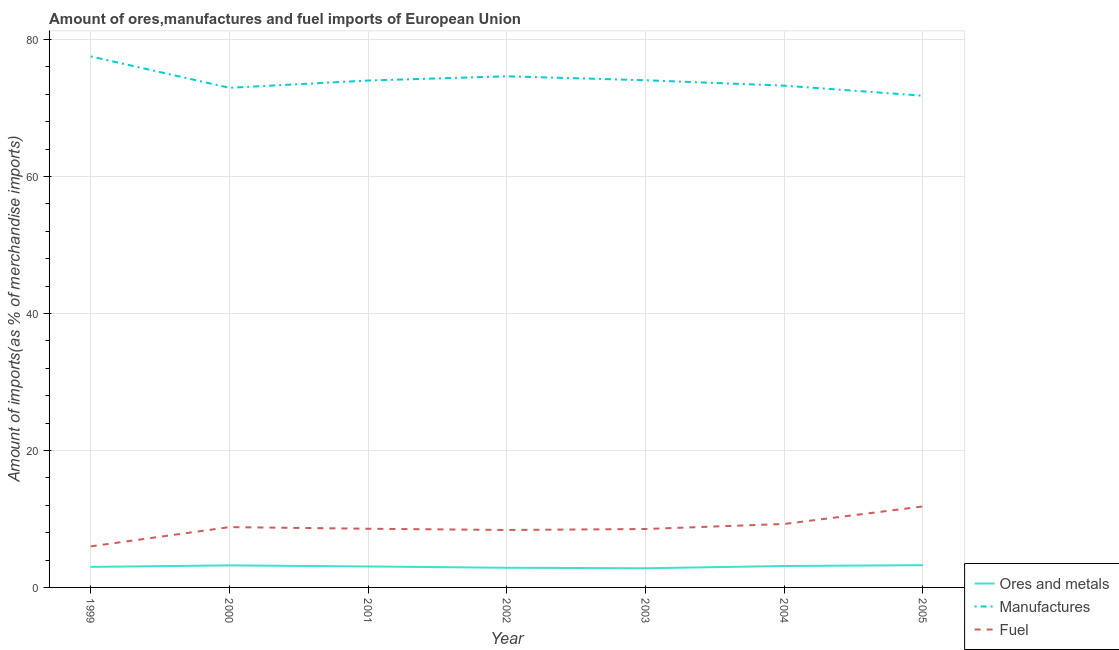What is the percentage of manufactures imports in 2002?
Make the answer very short. 74.62. Across all years, what is the maximum percentage of ores and metals imports?
Your answer should be very brief. 3.25. Across all years, what is the minimum percentage of ores and metals imports?
Offer a terse response. 2.8. In which year was the percentage of fuel imports minimum?
Give a very brief answer. 1999. What is the total percentage of ores and metals imports in the graph?
Offer a terse response. 21.32. What is the difference between the percentage of fuel imports in 2000 and that in 2002?
Your response must be concise. 0.42. What is the difference between the percentage of ores and metals imports in 1999 and the percentage of manufactures imports in 2005?
Your answer should be very brief. -68.78. What is the average percentage of manufactures imports per year?
Ensure brevity in your answer.  74.02. In the year 2001, what is the difference between the percentage of fuel imports and percentage of manufactures imports?
Keep it short and to the point. -65.43. What is the ratio of the percentage of manufactures imports in 2003 to that in 2004?
Ensure brevity in your answer.  1.01. What is the difference between the highest and the second highest percentage of manufactures imports?
Give a very brief answer. 2.9. What is the difference between the highest and the lowest percentage of fuel imports?
Your answer should be compact. 5.83. Is the sum of the percentage of fuel imports in 2000 and 2004 greater than the maximum percentage of manufactures imports across all years?
Provide a short and direct response. No. Is it the case that in every year, the sum of the percentage of ores and metals imports and percentage of manufactures imports is greater than the percentage of fuel imports?
Your answer should be very brief. Yes. Does the percentage of manufactures imports monotonically increase over the years?
Offer a terse response. No. Is the percentage of fuel imports strictly greater than the percentage of ores and metals imports over the years?
Your response must be concise. Yes. Is the percentage of fuel imports strictly less than the percentage of ores and metals imports over the years?
Offer a very short reply. No. What is the difference between two consecutive major ticks on the Y-axis?
Offer a very short reply. 20. Are the values on the major ticks of Y-axis written in scientific E-notation?
Your response must be concise. No. Does the graph contain grids?
Ensure brevity in your answer.  Yes. How are the legend labels stacked?
Your answer should be compact. Vertical. What is the title of the graph?
Keep it short and to the point. Amount of ores,manufactures and fuel imports of European Union. What is the label or title of the X-axis?
Your answer should be compact. Year. What is the label or title of the Y-axis?
Offer a terse response. Amount of imports(as % of merchandise imports). What is the Amount of imports(as % of merchandise imports) of Ores and metals in 1999?
Your answer should be compact. 3. What is the Amount of imports(as % of merchandise imports) in Manufactures in 1999?
Provide a short and direct response. 77.52. What is the Amount of imports(as % of merchandise imports) in Fuel in 1999?
Give a very brief answer. 5.99. What is the Amount of imports(as % of merchandise imports) of Ores and metals in 2000?
Your response must be concise. 3.22. What is the Amount of imports(as % of merchandise imports) of Manufactures in 2000?
Ensure brevity in your answer.  72.94. What is the Amount of imports(as % of merchandise imports) of Fuel in 2000?
Provide a short and direct response. 8.81. What is the Amount of imports(as % of merchandise imports) of Ores and metals in 2001?
Provide a succinct answer. 3.06. What is the Amount of imports(as % of merchandise imports) of Manufactures in 2001?
Your response must be concise. 74. What is the Amount of imports(as % of merchandise imports) of Fuel in 2001?
Offer a very short reply. 8.57. What is the Amount of imports(as % of merchandise imports) of Ores and metals in 2002?
Keep it short and to the point. 2.87. What is the Amount of imports(as % of merchandise imports) in Manufactures in 2002?
Offer a terse response. 74.62. What is the Amount of imports(as % of merchandise imports) of Fuel in 2002?
Ensure brevity in your answer.  8.39. What is the Amount of imports(as % of merchandise imports) in Ores and metals in 2003?
Make the answer very short. 2.8. What is the Amount of imports(as % of merchandise imports) in Manufactures in 2003?
Give a very brief answer. 74.04. What is the Amount of imports(as % of merchandise imports) in Fuel in 2003?
Provide a succinct answer. 8.53. What is the Amount of imports(as % of merchandise imports) of Ores and metals in 2004?
Offer a very short reply. 3.13. What is the Amount of imports(as % of merchandise imports) of Manufactures in 2004?
Provide a short and direct response. 73.25. What is the Amount of imports(as % of merchandise imports) in Fuel in 2004?
Keep it short and to the point. 9.26. What is the Amount of imports(as % of merchandise imports) of Ores and metals in 2005?
Keep it short and to the point. 3.25. What is the Amount of imports(as % of merchandise imports) of Manufactures in 2005?
Provide a short and direct response. 71.78. What is the Amount of imports(as % of merchandise imports) of Fuel in 2005?
Your response must be concise. 11.82. Across all years, what is the maximum Amount of imports(as % of merchandise imports) of Ores and metals?
Provide a short and direct response. 3.25. Across all years, what is the maximum Amount of imports(as % of merchandise imports) of Manufactures?
Offer a terse response. 77.52. Across all years, what is the maximum Amount of imports(as % of merchandise imports) in Fuel?
Provide a short and direct response. 11.82. Across all years, what is the minimum Amount of imports(as % of merchandise imports) in Ores and metals?
Your answer should be very brief. 2.8. Across all years, what is the minimum Amount of imports(as % of merchandise imports) in Manufactures?
Give a very brief answer. 71.78. Across all years, what is the minimum Amount of imports(as % of merchandise imports) of Fuel?
Your response must be concise. 5.99. What is the total Amount of imports(as % of merchandise imports) in Ores and metals in the graph?
Make the answer very short. 21.32. What is the total Amount of imports(as % of merchandise imports) in Manufactures in the graph?
Offer a terse response. 518.14. What is the total Amount of imports(as % of merchandise imports) in Fuel in the graph?
Provide a short and direct response. 61.37. What is the difference between the Amount of imports(as % of merchandise imports) in Ores and metals in 1999 and that in 2000?
Your answer should be compact. -0.22. What is the difference between the Amount of imports(as % of merchandise imports) in Manufactures in 1999 and that in 2000?
Offer a very short reply. 4.58. What is the difference between the Amount of imports(as % of merchandise imports) in Fuel in 1999 and that in 2000?
Your answer should be compact. -2.81. What is the difference between the Amount of imports(as % of merchandise imports) in Ores and metals in 1999 and that in 2001?
Make the answer very short. -0.06. What is the difference between the Amount of imports(as % of merchandise imports) of Manufactures in 1999 and that in 2001?
Offer a terse response. 3.52. What is the difference between the Amount of imports(as % of merchandise imports) of Fuel in 1999 and that in 2001?
Make the answer very short. -2.57. What is the difference between the Amount of imports(as % of merchandise imports) of Ores and metals in 1999 and that in 2002?
Offer a very short reply. 0.13. What is the difference between the Amount of imports(as % of merchandise imports) in Manufactures in 1999 and that in 2002?
Provide a succinct answer. 2.9. What is the difference between the Amount of imports(as % of merchandise imports) of Fuel in 1999 and that in 2002?
Your answer should be compact. -2.39. What is the difference between the Amount of imports(as % of merchandise imports) of Ores and metals in 1999 and that in 2003?
Provide a short and direct response. 0.2. What is the difference between the Amount of imports(as % of merchandise imports) in Manufactures in 1999 and that in 2003?
Ensure brevity in your answer.  3.48. What is the difference between the Amount of imports(as % of merchandise imports) of Fuel in 1999 and that in 2003?
Provide a short and direct response. -2.53. What is the difference between the Amount of imports(as % of merchandise imports) of Ores and metals in 1999 and that in 2004?
Give a very brief answer. -0.13. What is the difference between the Amount of imports(as % of merchandise imports) in Manufactures in 1999 and that in 2004?
Provide a succinct answer. 4.27. What is the difference between the Amount of imports(as % of merchandise imports) of Fuel in 1999 and that in 2004?
Provide a succinct answer. -3.27. What is the difference between the Amount of imports(as % of merchandise imports) in Ores and metals in 1999 and that in 2005?
Ensure brevity in your answer.  -0.25. What is the difference between the Amount of imports(as % of merchandise imports) in Manufactures in 1999 and that in 2005?
Provide a succinct answer. 5.74. What is the difference between the Amount of imports(as % of merchandise imports) in Fuel in 1999 and that in 2005?
Your answer should be very brief. -5.83. What is the difference between the Amount of imports(as % of merchandise imports) of Ores and metals in 2000 and that in 2001?
Your response must be concise. 0.16. What is the difference between the Amount of imports(as % of merchandise imports) of Manufactures in 2000 and that in 2001?
Ensure brevity in your answer.  -1.06. What is the difference between the Amount of imports(as % of merchandise imports) of Fuel in 2000 and that in 2001?
Keep it short and to the point. 0.24. What is the difference between the Amount of imports(as % of merchandise imports) of Ores and metals in 2000 and that in 2002?
Offer a terse response. 0.35. What is the difference between the Amount of imports(as % of merchandise imports) in Manufactures in 2000 and that in 2002?
Your response must be concise. -1.68. What is the difference between the Amount of imports(as % of merchandise imports) of Fuel in 2000 and that in 2002?
Provide a short and direct response. 0.42. What is the difference between the Amount of imports(as % of merchandise imports) of Ores and metals in 2000 and that in 2003?
Keep it short and to the point. 0.42. What is the difference between the Amount of imports(as % of merchandise imports) of Manufactures in 2000 and that in 2003?
Give a very brief answer. -1.1. What is the difference between the Amount of imports(as % of merchandise imports) in Fuel in 2000 and that in 2003?
Provide a short and direct response. 0.28. What is the difference between the Amount of imports(as % of merchandise imports) in Ores and metals in 2000 and that in 2004?
Your answer should be very brief. 0.09. What is the difference between the Amount of imports(as % of merchandise imports) of Manufactures in 2000 and that in 2004?
Make the answer very short. -0.32. What is the difference between the Amount of imports(as % of merchandise imports) in Fuel in 2000 and that in 2004?
Give a very brief answer. -0.46. What is the difference between the Amount of imports(as % of merchandise imports) of Ores and metals in 2000 and that in 2005?
Your response must be concise. -0.03. What is the difference between the Amount of imports(as % of merchandise imports) in Manufactures in 2000 and that in 2005?
Your answer should be compact. 1.16. What is the difference between the Amount of imports(as % of merchandise imports) in Fuel in 2000 and that in 2005?
Your response must be concise. -3.02. What is the difference between the Amount of imports(as % of merchandise imports) of Ores and metals in 2001 and that in 2002?
Offer a terse response. 0.19. What is the difference between the Amount of imports(as % of merchandise imports) in Manufactures in 2001 and that in 2002?
Provide a short and direct response. -0.62. What is the difference between the Amount of imports(as % of merchandise imports) of Fuel in 2001 and that in 2002?
Offer a very short reply. 0.18. What is the difference between the Amount of imports(as % of merchandise imports) of Ores and metals in 2001 and that in 2003?
Ensure brevity in your answer.  0.26. What is the difference between the Amount of imports(as % of merchandise imports) in Manufactures in 2001 and that in 2003?
Provide a short and direct response. -0.04. What is the difference between the Amount of imports(as % of merchandise imports) of Fuel in 2001 and that in 2003?
Provide a succinct answer. 0.04. What is the difference between the Amount of imports(as % of merchandise imports) of Ores and metals in 2001 and that in 2004?
Offer a very short reply. -0.07. What is the difference between the Amount of imports(as % of merchandise imports) of Manufactures in 2001 and that in 2004?
Your answer should be compact. 0.75. What is the difference between the Amount of imports(as % of merchandise imports) in Fuel in 2001 and that in 2004?
Ensure brevity in your answer.  -0.7. What is the difference between the Amount of imports(as % of merchandise imports) of Ores and metals in 2001 and that in 2005?
Make the answer very short. -0.19. What is the difference between the Amount of imports(as % of merchandise imports) of Manufactures in 2001 and that in 2005?
Your response must be concise. 2.22. What is the difference between the Amount of imports(as % of merchandise imports) in Fuel in 2001 and that in 2005?
Offer a terse response. -3.26. What is the difference between the Amount of imports(as % of merchandise imports) in Ores and metals in 2002 and that in 2003?
Provide a succinct answer. 0.07. What is the difference between the Amount of imports(as % of merchandise imports) of Manufactures in 2002 and that in 2003?
Your answer should be compact. 0.58. What is the difference between the Amount of imports(as % of merchandise imports) in Fuel in 2002 and that in 2003?
Your answer should be compact. -0.14. What is the difference between the Amount of imports(as % of merchandise imports) of Ores and metals in 2002 and that in 2004?
Give a very brief answer. -0.26. What is the difference between the Amount of imports(as % of merchandise imports) in Manufactures in 2002 and that in 2004?
Keep it short and to the point. 1.36. What is the difference between the Amount of imports(as % of merchandise imports) of Fuel in 2002 and that in 2004?
Provide a succinct answer. -0.88. What is the difference between the Amount of imports(as % of merchandise imports) of Ores and metals in 2002 and that in 2005?
Ensure brevity in your answer.  -0.38. What is the difference between the Amount of imports(as % of merchandise imports) of Manufactures in 2002 and that in 2005?
Offer a very short reply. 2.84. What is the difference between the Amount of imports(as % of merchandise imports) of Fuel in 2002 and that in 2005?
Offer a very short reply. -3.44. What is the difference between the Amount of imports(as % of merchandise imports) in Ores and metals in 2003 and that in 2004?
Your answer should be very brief. -0.33. What is the difference between the Amount of imports(as % of merchandise imports) of Manufactures in 2003 and that in 2004?
Give a very brief answer. 0.79. What is the difference between the Amount of imports(as % of merchandise imports) in Fuel in 2003 and that in 2004?
Make the answer very short. -0.74. What is the difference between the Amount of imports(as % of merchandise imports) in Ores and metals in 2003 and that in 2005?
Make the answer very short. -0.45. What is the difference between the Amount of imports(as % of merchandise imports) in Manufactures in 2003 and that in 2005?
Provide a short and direct response. 2.26. What is the difference between the Amount of imports(as % of merchandise imports) of Fuel in 2003 and that in 2005?
Ensure brevity in your answer.  -3.3. What is the difference between the Amount of imports(as % of merchandise imports) in Ores and metals in 2004 and that in 2005?
Your answer should be compact. -0.12. What is the difference between the Amount of imports(as % of merchandise imports) in Manufactures in 2004 and that in 2005?
Keep it short and to the point. 1.47. What is the difference between the Amount of imports(as % of merchandise imports) of Fuel in 2004 and that in 2005?
Offer a terse response. -2.56. What is the difference between the Amount of imports(as % of merchandise imports) of Ores and metals in 1999 and the Amount of imports(as % of merchandise imports) of Manufactures in 2000?
Make the answer very short. -69.94. What is the difference between the Amount of imports(as % of merchandise imports) in Ores and metals in 1999 and the Amount of imports(as % of merchandise imports) in Fuel in 2000?
Provide a succinct answer. -5.81. What is the difference between the Amount of imports(as % of merchandise imports) of Manufactures in 1999 and the Amount of imports(as % of merchandise imports) of Fuel in 2000?
Ensure brevity in your answer.  68.71. What is the difference between the Amount of imports(as % of merchandise imports) in Ores and metals in 1999 and the Amount of imports(as % of merchandise imports) in Manufactures in 2001?
Provide a succinct answer. -71. What is the difference between the Amount of imports(as % of merchandise imports) in Ores and metals in 1999 and the Amount of imports(as % of merchandise imports) in Fuel in 2001?
Your answer should be compact. -5.57. What is the difference between the Amount of imports(as % of merchandise imports) in Manufactures in 1999 and the Amount of imports(as % of merchandise imports) in Fuel in 2001?
Your response must be concise. 68.95. What is the difference between the Amount of imports(as % of merchandise imports) of Ores and metals in 1999 and the Amount of imports(as % of merchandise imports) of Manufactures in 2002?
Offer a terse response. -71.62. What is the difference between the Amount of imports(as % of merchandise imports) in Ores and metals in 1999 and the Amount of imports(as % of merchandise imports) in Fuel in 2002?
Give a very brief answer. -5.39. What is the difference between the Amount of imports(as % of merchandise imports) in Manufactures in 1999 and the Amount of imports(as % of merchandise imports) in Fuel in 2002?
Your response must be concise. 69.13. What is the difference between the Amount of imports(as % of merchandise imports) of Ores and metals in 1999 and the Amount of imports(as % of merchandise imports) of Manufactures in 2003?
Your response must be concise. -71.04. What is the difference between the Amount of imports(as % of merchandise imports) in Ores and metals in 1999 and the Amount of imports(as % of merchandise imports) in Fuel in 2003?
Give a very brief answer. -5.53. What is the difference between the Amount of imports(as % of merchandise imports) in Manufactures in 1999 and the Amount of imports(as % of merchandise imports) in Fuel in 2003?
Ensure brevity in your answer.  68.99. What is the difference between the Amount of imports(as % of merchandise imports) of Ores and metals in 1999 and the Amount of imports(as % of merchandise imports) of Manufactures in 2004?
Your answer should be compact. -70.25. What is the difference between the Amount of imports(as % of merchandise imports) in Ores and metals in 1999 and the Amount of imports(as % of merchandise imports) in Fuel in 2004?
Your response must be concise. -6.27. What is the difference between the Amount of imports(as % of merchandise imports) in Manufactures in 1999 and the Amount of imports(as % of merchandise imports) in Fuel in 2004?
Your answer should be compact. 68.25. What is the difference between the Amount of imports(as % of merchandise imports) of Ores and metals in 1999 and the Amount of imports(as % of merchandise imports) of Manufactures in 2005?
Offer a very short reply. -68.78. What is the difference between the Amount of imports(as % of merchandise imports) in Ores and metals in 1999 and the Amount of imports(as % of merchandise imports) in Fuel in 2005?
Provide a succinct answer. -8.83. What is the difference between the Amount of imports(as % of merchandise imports) of Manufactures in 1999 and the Amount of imports(as % of merchandise imports) of Fuel in 2005?
Offer a terse response. 65.69. What is the difference between the Amount of imports(as % of merchandise imports) in Ores and metals in 2000 and the Amount of imports(as % of merchandise imports) in Manufactures in 2001?
Ensure brevity in your answer.  -70.78. What is the difference between the Amount of imports(as % of merchandise imports) of Ores and metals in 2000 and the Amount of imports(as % of merchandise imports) of Fuel in 2001?
Provide a short and direct response. -5.35. What is the difference between the Amount of imports(as % of merchandise imports) of Manufactures in 2000 and the Amount of imports(as % of merchandise imports) of Fuel in 2001?
Make the answer very short. 64.37. What is the difference between the Amount of imports(as % of merchandise imports) in Ores and metals in 2000 and the Amount of imports(as % of merchandise imports) in Manufactures in 2002?
Provide a short and direct response. -71.4. What is the difference between the Amount of imports(as % of merchandise imports) in Ores and metals in 2000 and the Amount of imports(as % of merchandise imports) in Fuel in 2002?
Provide a succinct answer. -5.17. What is the difference between the Amount of imports(as % of merchandise imports) of Manufactures in 2000 and the Amount of imports(as % of merchandise imports) of Fuel in 2002?
Make the answer very short. 64.55. What is the difference between the Amount of imports(as % of merchandise imports) of Ores and metals in 2000 and the Amount of imports(as % of merchandise imports) of Manufactures in 2003?
Keep it short and to the point. -70.82. What is the difference between the Amount of imports(as % of merchandise imports) of Ores and metals in 2000 and the Amount of imports(as % of merchandise imports) of Fuel in 2003?
Your response must be concise. -5.31. What is the difference between the Amount of imports(as % of merchandise imports) in Manufactures in 2000 and the Amount of imports(as % of merchandise imports) in Fuel in 2003?
Offer a terse response. 64.41. What is the difference between the Amount of imports(as % of merchandise imports) of Ores and metals in 2000 and the Amount of imports(as % of merchandise imports) of Manufactures in 2004?
Keep it short and to the point. -70.04. What is the difference between the Amount of imports(as % of merchandise imports) of Ores and metals in 2000 and the Amount of imports(as % of merchandise imports) of Fuel in 2004?
Provide a succinct answer. -6.05. What is the difference between the Amount of imports(as % of merchandise imports) in Manufactures in 2000 and the Amount of imports(as % of merchandise imports) in Fuel in 2004?
Provide a short and direct response. 63.67. What is the difference between the Amount of imports(as % of merchandise imports) of Ores and metals in 2000 and the Amount of imports(as % of merchandise imports) of Manufactures in 2005?
Give a very brief answer. -68.56. What is the difference between the Amount of imports(as % of merchandise imports) in Ores and metals in 2000 and the Amount of imports(as % of merchandise imports) in Fuel in 2005?
Give a very brief answer. -8.61. What is the difference between the Amount of imports(as % of merchandise imports) of Manufactures in 2000 and the Amount of imports(as % of merchandise imports) of Fuel in 2005?
Make the answer very short. 61.11. What is the difference between the Amount of imports(as % of merchandise imports) of Ores and metals in 2001 and the Amount of imports(as % of merchandise imports) of Manufactures in 2002?
Make the answer very short. -71.56. What is the difference between the Amount of imports(as % of merchandise imports) of Ores and metals in 2001 and the Amount of imports(as % of merchandise imports) of Fuel in 2002?
Ensure brevity in your answer.  -5.33. What is the difference between the Amount of imports(as % of merchandise imports) in Manufactures in 2001 and the Amount of imports(as % of merchandise imports) in Fuel in 2002?
Offer a terse response. 65.61. What is the difference between the Amount of imports(as % of merchandise imports) of Ores and metals in 2001 and the Amount of imports(as % of merchandise imports) of Manufactures in 2003?
Provide a short and direct response. -70.98. What is the difference between the Amount of imports(as % of merchandise imports) in Ores and metals in 2001 and the Amount of imports(as % of merchandise imports) in Fuel in 2003?
Provide a succinct answer. -5.47. What is the difference between the Amount of imports(as % of merchandise imports) of Manufactures in 2001 and the Amount of imports(as % of merchandise imports) of Fuel in 2003?
Your answer should be compact. 65.47. What is the difference between the Amount of imports(as % of merchandise imports) of Ores and metals in 2001 and the Amount of imports(as % of merchandise imports) of Manufactures in 2004?
Your answer should be compact. -70.19. What is the difference between the Amount of imports(as % of merchandise imports) in Ores and metals in 2001 and the Amount of imports(as % of merchandise imports) in Fuel in 2004?
Make the answer very short. -6.2. What is the difference between the Amount of imports(as % of merchandise imports) in Manufactures in 2001 and the Amount of imports(as % of merchandise imports) in Fuel in 2004?
Keep it short and to the point. 64.73. What is the difference between the Amount of imports(as % of merchandise imports) of Ores and metals in 2001 and the Amount of imports(as % of merchandise imports) of Manufactures in 2005?
Provide a succinct answer. -68.72. What is the difference between the Amount of imports(as % of merchandise imports) of Ores and metals in 2001 and the Amount of imports(as % of merchandise imports) of Fuel in 2005?
Ensure brevity in your answer.  -8.76. What is the difference between the Amount of imports(as % of merchandise imports) of Manufactures in 2001 and the Amount of imports(as % of merchandise imports) of Fuel in 2005?
Keep it short and to the point. 62.17. What is the difference between the Amount of imports(as % of merchandise imports) in Ores and metals in 2002 and the Amount of imports(as % of merchandise imports) in Manufactures in 2003?
Your answer should be very brief. -71.17. What is the difference between the Amount of imports(as % of merchandise imports) in Ores and metals in 2002 and the Amount of imports(as % of merchandise imports) in Fuel in 2003?
Your answer should be very brief. -5.66. What is the difference between the Amount of imports(as % of merchandise imports) of Manufactures in 2002 and the Amount of imports(as % of merchandise imports) of Fuel in 2003?
Offer a very short reply. 66.09. What is the difference between the Amount of imports(as % of merchandise imports) in Ores and metals in 2002 and the Amount of imports(as % of merchandise imports) in Manufactures in 2004?
Ensure brevity in your answer.  -70.38. What is the difference between the Amount of imports(as % of merchandise imports) in Ores and metals in 2002 and the Amount of imports(as % of merchandise imports) in Fuel in 2004?
Provide a short and direct response. -6.39. What is the difference between the Amount of imports(as % of merchandise imports) in Manufactures in 2002 and the Amount of imports(as % of merchandise imports) in Fuel in 2004?
Provide a short and direct response. 65.35. What is the difference between the Amount of imports(as % of merchandise imports) of Ores and metals in 2002 and the Amount of imports(as % of merchandise imports) of Manufactures in 2005?
Provide a short and direct response. -68.91. What is the difference between the Amount of imports(as % of merchandise imports) of Ores and metals in 2002 and the Amount of imports(as % of merchandise imports) of Fuel in 2005?
Give a very brief answer. -8.95. What is the difference between the Amount of imports(as % of merchandise imports) of Manufactures in 2002 and the Amount of imports(as % of merchandise imports) of Fuel in 2005?
Your response must be concise. 62.79. What is the difference between the Amount of imports(as % of merchandise imports) in Ores and metals in 2003 and the Amount of imports(as % of merchandise imports) in Manufactures in 2004?
Offer a terse response. -70.46. What is the difference between the Amount of imports(as % of merchandise imports) of Ores and metals in 2003 and the Amount of imports(as % of merchandise imports) of Fuel in 2004?
Give a very brief answer. -6.47. What is the difference between the Amount of imports(as % of merchandise imports) of Manufactures in 2003 and the Amount of imports(as % of merchandise imports) of Fuel in 2004?
Give a very brief answer. 64.78. What is the difference between the Amount of imports(as % of merchandise imports) in Ores and metals in 2003 and the Amount of imports(as % of merchandise imports) in Manufactures in 2005?
Provide a succinct answer. -68.98. What is the difference between the Amount of imports(as % of merchandise imports) of Ores and metals in 2003 and the Amount of imports(as % of merchandise imports) of Fuel in 2005?
Offer a terse response. -9.03. What is the difference between the Amount of imports(as % of merchandise imports) of Manufactures in 2003 and the Amount of imports(as % of merchandise imports) of Fuel in 2005?
Your answer should be very brief. 62.22. What is the difference between the Amount of imports(as % of merchandise imports) of Ores and metals in 2004 and the Amount of imports(as % of merchandise imports) of Manufactures in 2005?
Your response must be concise. -68.65. What is the difference between the Amount of imports(as % of merchandise imports) in Ores and metals in 2004 and the Amount of imports(as % of merchandise imports) in Fuel in 2005?
Keep it short and to the point. -8.7. What is the difference between the Amount of imports(as % of merchandise imports) in Manufactures in 2004 and the Amount of imports(as % of merchandise imports) in Fuel in 2005?
Offer a terse response. 61.43. What is the average Amount of imports(as % of merchandise imports) of Ores and metals per year?
Ensure brevity in your answer.  3.05. What is the average Amount of imports(as % of merchandise imports) in Manufactures per year?
Give a very brief answer. 74.02. What is the average Amount of imports(as % of merchandise imports) of Fuel per year?
Give a very brief answer. 8.77. In the year 1999, what is the difference between the Amount of imports(as % of merchandise imports) of Ores and metals and Amount of imports(as % of merchandise imports) of Manufactures?
Offer a terse response. -74.52. In the year 1999, what is the difference between the Amount of imports(as % of merchandise imports) in Ores and metals and Amount of imports(as % of merchandise imports) in Fuel?
Ensure brevity in your answer.  -3. In the year 1999, what is the difference between the Amount of imports(as % of merchandise imports) of Manufactures and Amount of imports(as % of merchandise imports) of Fuel?
Your answer should be compact. 71.52. In the year 2000, what is the difference between the Amount of imports(as % of merchandise imports) of Ores and metals and Amount of imports(as % of merchandise imports) of Manufactures?
Keep it short and to the point. -69.72. In the year 2000, what is the difference between the Amount of imports(as % of merchandise imports) in Ores and metals and Amount of imports(as % of merchandise imports) in Fuel?
Give a very brief answer. -5.59. In the year 2000, what is the difference between the Amount of imports(as % of merchandise imports) of Manufactures and Amount of imports(as % of merchandise imports) of Fuel?
Ensure brevity in your answer.  64.13. In the year 2001, what is the difference between the Amount of imports(as % of merchandise imports) in Ores and metals and Amount of imports(as % of merchandise imports) in Manufactures?
Your answer should be very brief. -70.94. In the year 2001, what is the difference between the Amount of imports(as % of merchandise imports) in Ores and metals and Amount of imports(as % of merchandise imports) in Fuel?
Provide a short and direct response. -5.51. In the year 2001, what is the difference between the Amount of imports(as % of merchandise imports) in Manufactures and Amount of imports(as % of merchandise imports) in Fuel?
Provide a short and direct response. 65.43. In the year 2002, what is the difference between the Amount of imports(as % of merchandise imports) in Ores and metals and Amount of imports(as % of merchandise imports) in Manufactures?
Your response must be concise. -71.75. In the year 2002, what is the difference between the Amount of imports(as % of merchandise imports) in Ores and metals and Amount of imports(as % of merchandise imports) in Fuel?
Keep it short and to the point. -5.52. In the year 2002, what is the difference between the Amount of imports(as % of merchandise imports) of Manufactures and Amount of imports(as % of merchandise imports) of Fuel?
Make the answer very short. 66.23. In the year 2003, what is the difference between the Amount of imports(as % of merchandise imports) of Ores and metals and Amount of imports(as % of merchandise imports) of Manufactures?
Your response must be concise. -71.24. In the year 2003, what is the difference between the Amount of imports(as % of merchandise imports) in Ores and metals and Amount of imports(as % of merchandise imports) in Fuel?
Ensure brevity in your answer.  -5.73. In the year 2003, what is the difference between the Amount of imports(as % of merchandise imports) in Manufactures and Amount of imports(as % of merchandise imports) in Fuel?
Your answer should be compact. 65.51. In the year 2004, what is the difference between the Amount of imports(as % of merchandise imports) in Ores and metals and Amount of imports(as % of merchandise imports) in Manufactures?
Offer a terse response. -70.12. In the year 2004, what is the difference between the Amount of imports(as % of merchandise imports) in Ores and metals and Amount of imports(as % of merchandise imports) in Fuel?
Provide a succinct answer. -6.14. In the year 2004, what is the difference between the Amount of imports(as % of merchandise imports) in Manufactures and Amount of imports(as % of merchandise imports) in Fuel?
Give a very brief answer. 63.99. In the year 2005, what is the difference between the Amount of imports(as % of merchandise imports) of Ores and metals and Amount of imports(as % of merchandise imports) of Manufactures?
Ensure brevity in your answer.  -68.53. In the year 2005, what is the difference between the Amount of imports(as % of merchandise imports) in Ores and metals and Amount of imports(as % of merchandise imports) in Fuel?
Provide a succinct answer. -8.58. In the year 2005, what is the difference between the Amount of imports(as % of merchandise imports) of Manufactures and Amount of imports(as % of merchandise imports) of Fuel?
Your answer should be compact. 59.96. What is the ratio of the Amount of imports(as % of merchandise imports) in Ores and metals in 1999 to that in 2000?
Give a very brief answer. 0.93. What is the ratio of the Amount of imports(as % of merchandise imports) of Manufactures in 1999 to that in 2000?
Ensure brevity in your answer.  1.06. What is the ratio of the Amount of imports(as % of merchandise imports) in Fuel in 1999 to that in 2000?
Offer a terse response. 0.68. What is the ratio of the Amount of imports(as % of merchandise imports) of Ores and metals in 1999 to that in 2001?
Provide a succinct answer. 0.98. What is the ratio of the Amount of imports(as % of merchandise imports) of Manufactures in 1999 to that in 2001?
Your response must be concise. 1.05. What is the ratio of the Amount of imports(as % of merchandise imports) of Fuel in 1999 to that in 2001?
Provide a short and direct response. 0.7. What is the ratio of the Amount of imports(as % of merchandise imports) of Ores and metals in 1999 to that in 2002?
Ensure brevity in your answer.  1.04. What is the ratio of the Amount of imports(as % of merchandise imports) in Manufactures in 1999 to that in 2002?
Provide a short and direct response. 1.04. What is the ratio of the Amount of imports(as % of merchandise imports) of Fuel in 1999 to that in 2002?
Your response must be concise. 0.71. What is the ratio of the Amount of imports(as % of merchandise imports) in Ores and metals in 1999 to that in 2003?
Keep it short and to the point. 1.07. What is the ratio of the Amount of imports(as % of merchandise imports) of Manufactures in 1999 to that in 2003?
Offer a terse response. 1.05. What is the ratio of the Amount of imports(as % of merchandise imports) in Fuel in 1999 to that in 2003?
Provide a short and direct response. 0.7. What is the ratio of the Amount of imports(as % of merchandise imports) in Ores and metals in 1999 to that in 2004?
Your response must be concise. 0.96. What is the ratio of the Amount of imports(as % of merchandise imports) of Manufactures in 1999 to that in 2004?
Keep it short and to the point. 1.06. What is the ratio of the Amount of imports(as % of merchandise imports) in Fuel in 1999 to that in 2004?
Make the answer very short. 0.65. What is the ratio of the Amount of imports(as % of merchandise imports) in Ores and metals in 1999 to that in 2005?
Your response must be concise. 0.92. What is the ratio of the Amount of imports(as % of merchandise imports) in Manufactures in 1999 to that in 2005?
Offer a terse response. 1.08. What is the ratio of the Amount of imports(as % of merchandise imports) in Fuel in 1999 to that in 2005?
Give a very brief answer. 0.51. What is the ratio of the Amount of imports(as % of merchandise imports) of Ores and metals in 2000 to that in 2001?
Your response must be concise. 1.05. What is the ratio of the Amount of imports(as % of merchandise imports) of Manufactures in 2000 to that in 2001?
Provide a succinct answer. 0.99. What is the ratio of the Amount of imports(as % of merchandise imports) in Fuel in 2000 to that in 2001?
Give a very brief answer. 1.03. What is the ratio of the Amount of imports(as % of merchandise imports) in Ores and metals in 2000 to that in 2002?
Make the answer very short. 1.12. What is the ratio of the Amount of imports(as % of merchandise imports) in Manufactures in 2000 to that in 2002?
Ensure brevity in your answer.  0.98. What is the ratio of the Amount of imports(as % of merchandise imports) of Fuel in 2000 to that in 2002?
Your response must be concise. 1.05. What is the ratio of the Amount of imports(as % of merchandise imports) in Ores and metals in 2000 to that in 2003?
Give a very brief answer. 1.15. What is the ratio of the Amount of imports(as % of merchandise imports) of Manufactures in 2000 to that in 2003?
Your answer should be compact. 0.99. What is the ratio of the Amount of imports(as % of merchandise imports) in Fuel in 2000 to that in 2003?
Provide a short and direct response. 1.03. What is the ratio of the Amount of imports(as % of merchandise imports) in Ores and metals in 2000 to that in 2004?
Your answer should be very brief. 1.03. What is the ratio of the Amount of imports(as % of merchandise imports) in Manufactures in 2000 to that in 2004?
Make the answer very short. 1. What is the ratio of the Amount of imports(as % of merchandise imports) in Fuel in 2000 to that in 2004?
Ensure brevity in your answer.  0.95. What is the ratio of the Amount of imports(as % of merchandise imports) of Ores and metals in 2000 to that in 2005?
Make the answer very short. 0.99. What is the ratio of the Amount of imports(as % of merchandise imports) of Manufactures in 2000 to that in 2005?
Your answer should be very brief. 1.02. What is the ratio of the Amount of imports(as % of merchandise imports) in Fuel in 2000 to that in 2005?
Keep it short and to the point. 0.74. What is the ratio of the Amount of imports(as % of merchandise imports) in Ores and metals in 2001 to that in 2002?
Provide a short and direct response. 1.07. What is the ratio of the Amount of imports(as % of merchandise imports) of Fuel in 2001 to that in 2002?
Make the answer very short. 1.02. What is the ratio of the Amount of imports(as % of merchandise imports) of Ores and metals in 2001 to that in 2003?
Your answer should be compact. 1.09. What is the ratio of the Amount of imports(as % of merchandise imports) of Fuel in 2001 to that in 2003?
Offer a terse response. 1. What is the ratio of the Amount of imports(as % of merchandise imports) in Ores and metals in 2001 to that in 2004?
Give a very brief answer. 0.98. What is the ratio of the Amount of imports(as % of merchandise imports) in Manufactures in 2001 to that in 2004?
Offer a terse response. 1.01. What is the ratio of the Amount of imports(as % of merchandise imports) of Fuel in 2001 to that in 2004?
Give a very brief answer. 0.92. What is the ratio of the Amount of imports(as % of merchandise imports) in Ores and metals in 2001 to that in 2005?
Provide a short and direct response. 0.94. What is the ratio of the Amount of imports(as % of merchandise imports) of Manufactures in 2001 to that in 2005?
Give a very brief answer. 1.03. What is the ratio of the Amount of imports(as % of merchandise imports) in Fuel in 2001 to that in 2005?
Make the answer very short. 0.72. What is the ratio of the Amount of imports(as % of merchandise imports) of Ores and metals in 2002 to that in 2003?
Offer a terse response. 1.03. What is the ratio of the Amount of imports(as % of merchandise imports) in Fuel in 2002 to that in 2003?
Keep it short and to the point. 0.98. What is the ratio of the Amount of imports(as % of merchandise imports) of Ores and metals in 2002 to that in 2004?
Offer a very short reply. 0.92. What is the ratio of the Amount of imports(as % of merchandise imports) in Manufactures in 2002 to that in 2004?
Keep it short and to the point. 1.02. What is the ratio of the Amount of imports(as % of merchandise imports) in Fuel in 2002 to that in 2004?
Ensure brevity in your answer.  0.91. What is the ratio of the Amount of imports(as % of merchandise imports) in Ores and metals in 2002 to that in 2005?
Provide a short and direct response. 0.88. What is the ratio of the Amount of imports(as % of merchandise imports) in Manufactures in 2002 to that in 2005?
Ensure brevity in your answer.  1.04. What is the ratio of the Amount of imports(as % of merchandise imports) of Fuel in 2002 to that in 2005?
Provide a succinct answer. 0.71. What is the ratio of the Amount of imports(as % of merchandise imports) of Ores and metals in 2003 to that in 2004?
Your answer should be compact. 0.89. What is the ratio of the Amount of imports(as % of merchandise imports) in Manufactures in 2003 to that in 2004?
Ensure brevity in your answer.  1.01. What is the ratio of the Amount of imports(as % of merchandise imports) in Fuel in 2003 to that in 2004?
Provide a succinct answer. 0.92. What is the ratio of the Amount of imports(as % of merchandise imports) in Ores and metals in 2003 to that in 2005?
Offer a terse response. 0.86. What is the ratio of the Amount of imports(as % of merchandise imports) in Manufactures in 2003 to that in 2005?
Your answer should be very brief. 1.03. What is the ratio of the Amount of imports(as % of merchandise imports) of Fuel in 2003 to that in 2005?
Make the answer very short. 0.72. What is the ratio of the Amount of imports(as % of merchandise imports) of Ores and metals in 2004 to that in 2005?
Give a very brief answer. 0.96. What is the ratio of the Amount of imports(as % of merchandise imports) in Manufactures in 2004 to that in 2005?
Make the answer very short. 1.02. What is the ratio of the Amount of imports(as % of merchandise imports) of Fuel in 2004 to that in 2005?
Make the answer very short. 0.78. What is the difference between the highest and the second highest Amount of imports(as % of merchandise imports) in Ores and metals?
Your answer should be very brief. 0.03. What is the difference between the highest and the second highest Amount of imports(as % of merchandise imports) in Manufactures?
Your answer should be compact. 2.9. What is the difference between the highest and the second highest Amount of imports(as % of merchandise imports) in Fuel?
Your response must be concise. 2.56. What is the difference between the highest and the lowest Amount of imports(as % of merchandise imports) of Ores and metals?
Your answer should be compact. 0.45. What is the difference between the highest and the lowest Amount of imports(as % of merchandise imports) in Manufactures?
Make the answer very short. 5.74. What is the difference between the highest and the lowest Amount of imports(as % of merchandise imports) of Fuel?
Keep it short and to the point. 5.83. 